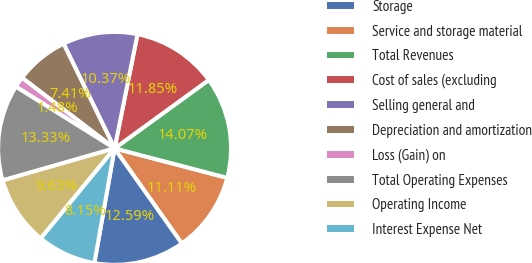Convert chart to OTSL. <chart><loc_0><loc_0><loc_500><loc_500><pie_chart><fcel>Storage<fcel>Service and storage material<fcel>Total Revenues<fcel>Cost of sales (excluding<fcel>Selling general and<fcel>Depreciation and amortization<fcel>Loss (Gain) on<fcel>Total Operating Expenses<fcel>Operating Income<fcel>Interest Expense Net<nl><fcel>12.59%<fcel>11.11%<fcel>14.07%<fcel>11.85%<fcel>10.37%<fcel>7.41%<fcel>1.48%<fcel>13.33%<fcel>9.63%<fcel>8.15%<nl></chart> 